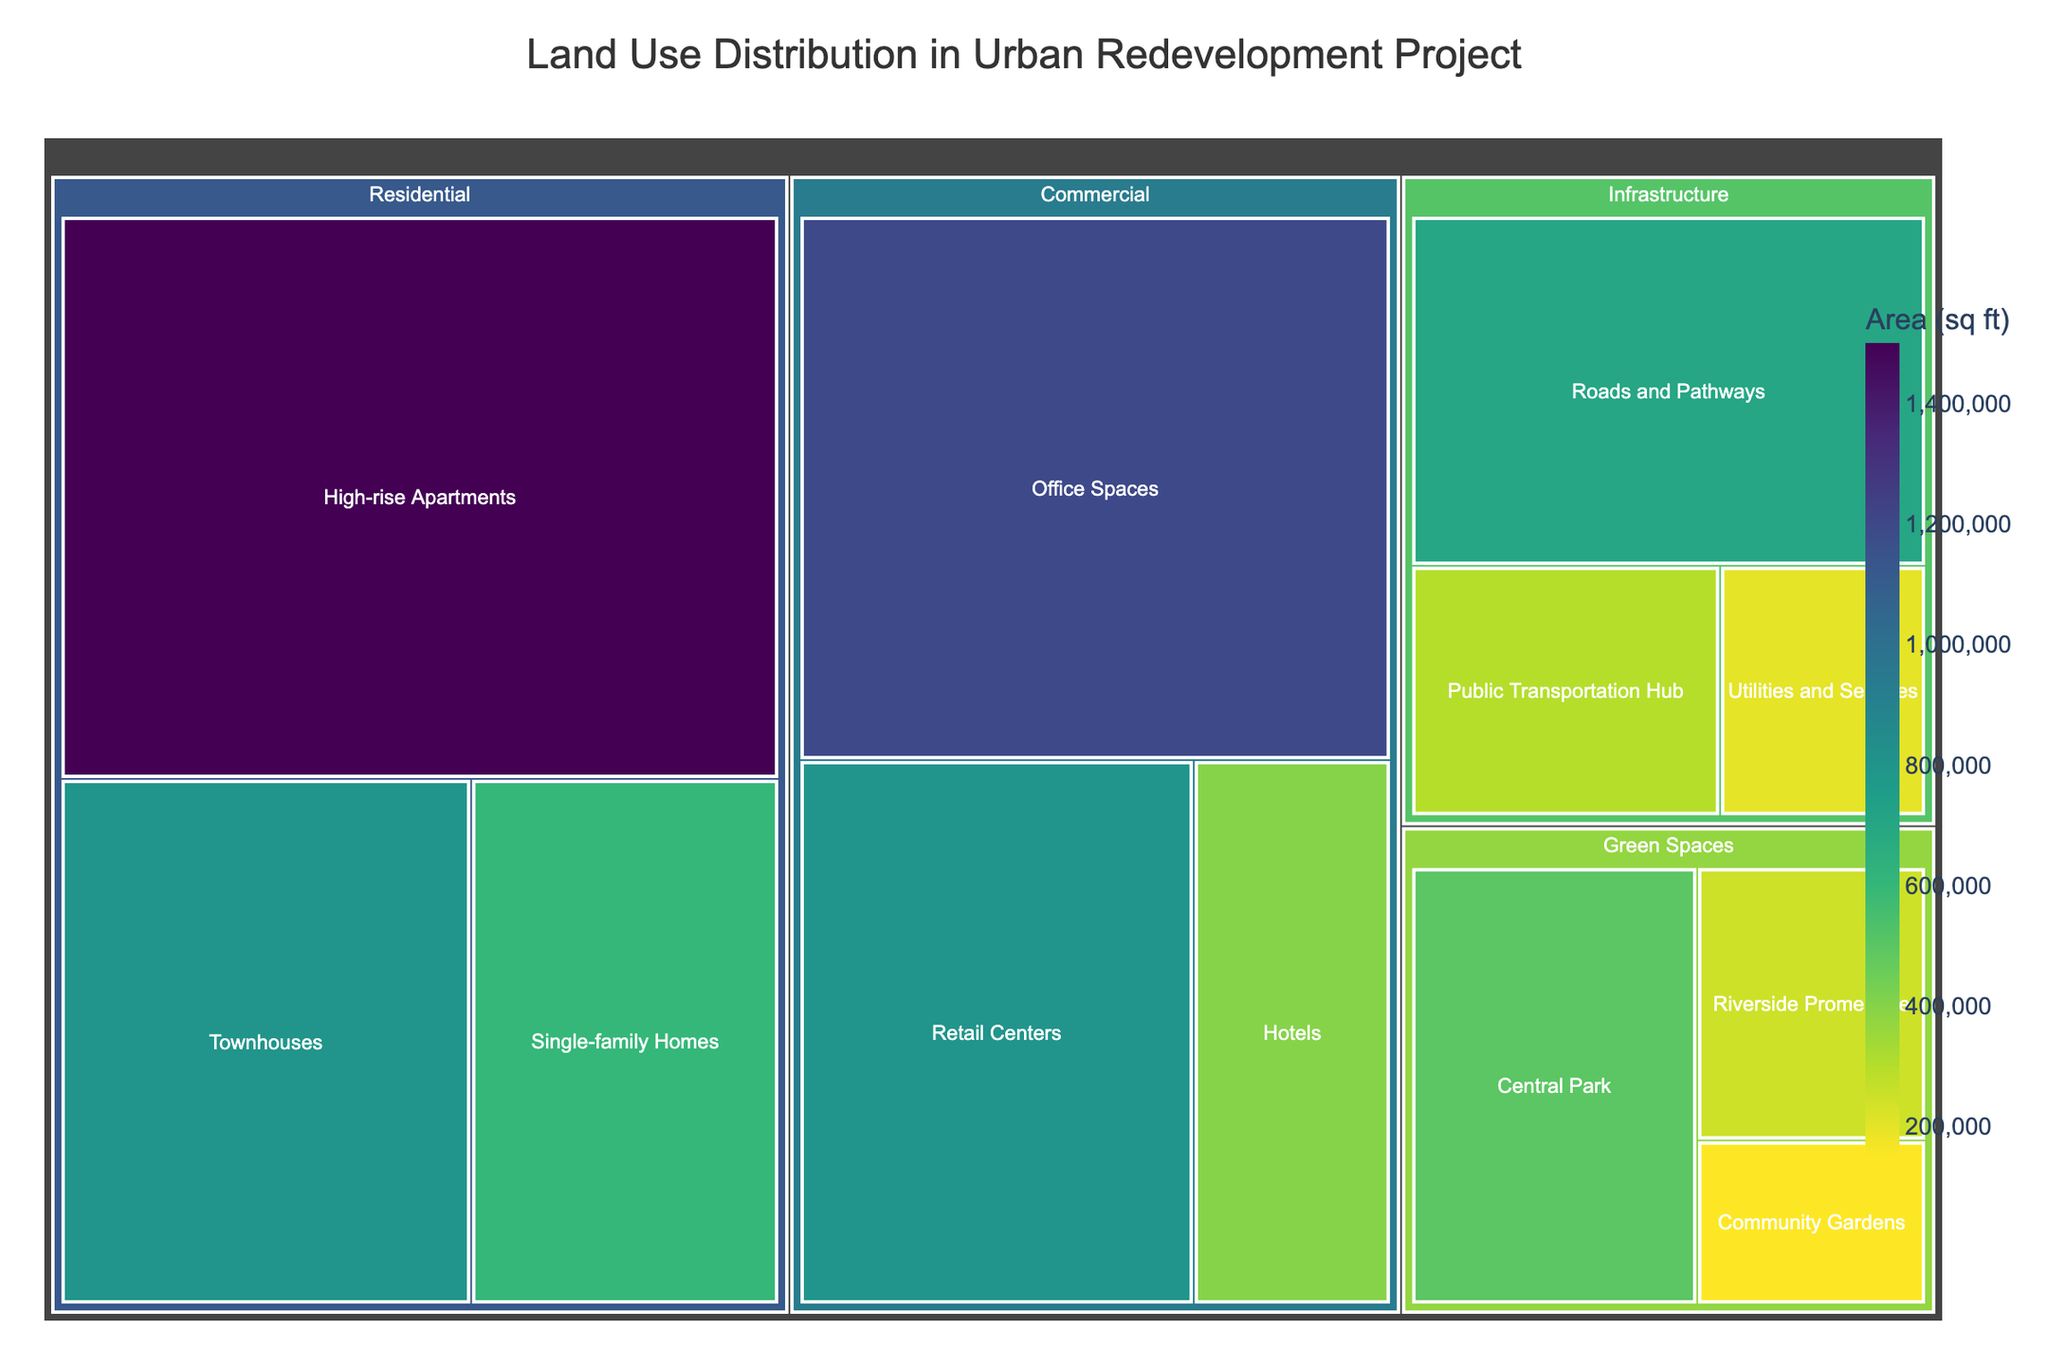What's the total area allocated to Residential use? Summing up the areas of High-rise Apartments, Townhouses, and Single-family Homes: 1,500,000 + 800,000 + 600,000 = 2,900,000 sq ft
Answer: 2,900,000 sq ft Which subcategory has the largest area within the Commercial category? Within Commercial, the areas are Office Spaces (1,200,000 sq ft), Retail Centers (800,000 sq ft), and Hotels (400,000 sq ft). Office Spaces is the largest.
Answer: Office Spaces How does the area of Central Park compare to the combined area of Community Gardens and Riverside Promenade? Central Park is 500,000 sq ft. Community Gardens and Riverside Promenade combined are 150,000 + 250,000 = 400,000 sq ft. Central Park is larger.
Answer: Central Park is larger What's the smallest subcategory within the Infrastructure category? Comparing Roads and Pathways (700,000 sq ft), Public Transportation Hub (300,000 sq ft), and Utilities and Services (200,000 sq ft), Utilities and Services is the smallest.
Answer: Utilities and Services What percentage of the total land use is allocated to Green Spaces? Total area is 7,600,000 sq ft. Green Spaces is 500,000 + 150,000 + 250,000 = 900,000 sq ft. The percentage is (900,000 / 7,600,000) * 100 ≈ 11.84%
Answer: approx. 11.84% How does the allocation for Commercial use compare to that for Residential use? Commercial is 1,200,000 + 800,000 + 400,000 = 2,400,000 sq ft. Residential is 2,900,000 sq ft. Residential is larger.
Answer: Residential is larger What is the average area per subcategory in the Green Spaces category? Green Spaces total area is 900,000 sq ft across 3 subcategories. Average is 900,000 / 3 = 300,000 sq ft
Answer: 300,000 sq ft Which category has the second largest total area allocation and what is that total area? Summing total areas of each category: Residential (2,900,000 sq ft), Commercial (2,400,000 sq ft), Green Spaces (900,000 sq ft), Infrastructure (1,200,000 sq ft). Second largest is Infrastructure.
Answer: Infrastructure, 1,200,000 sq ft 